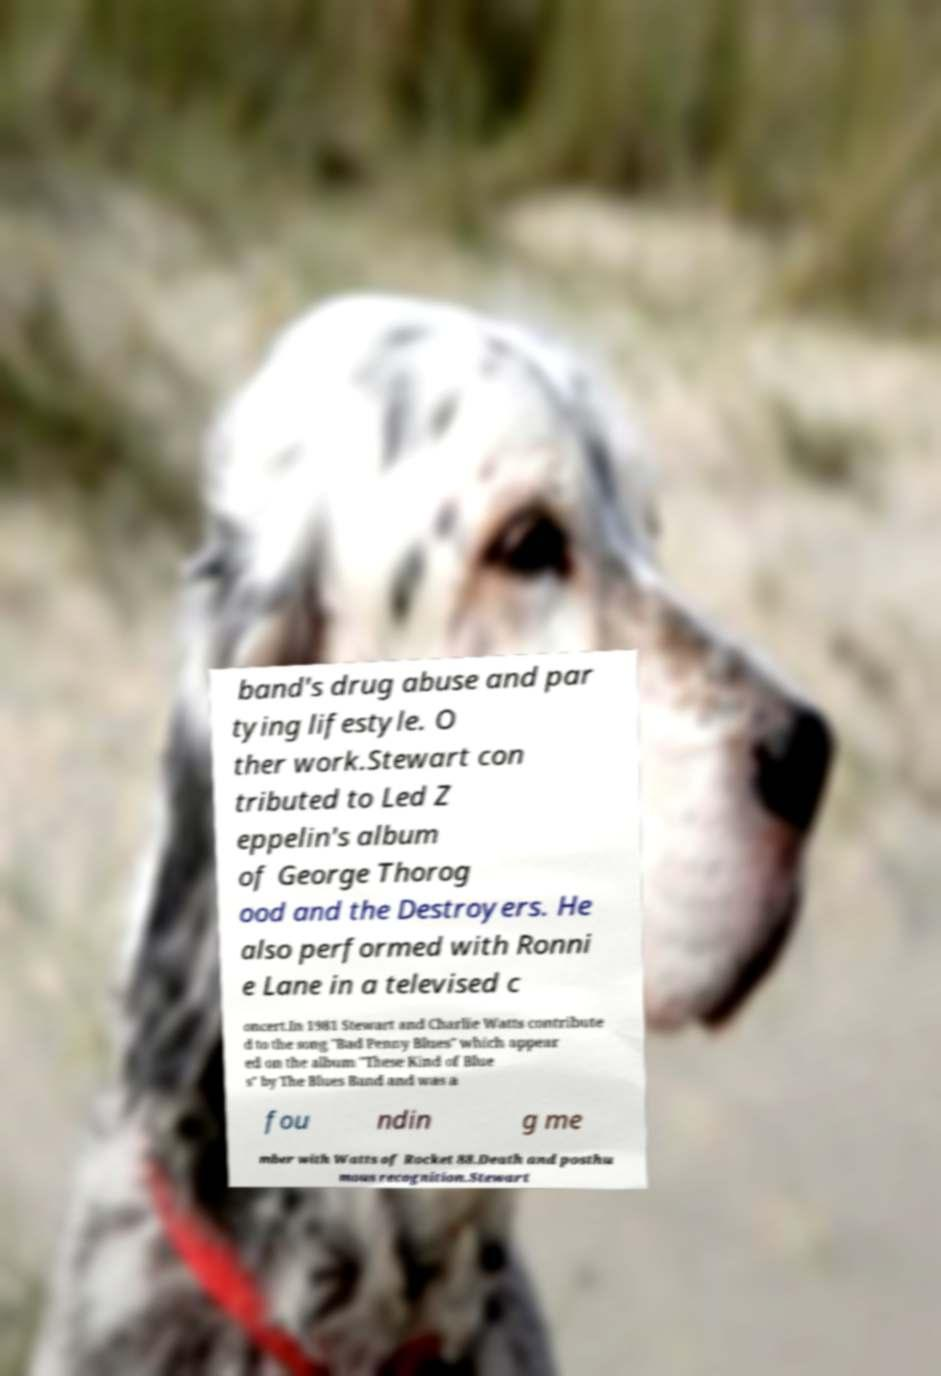What messages or text are displayed in this image? I need them in a readable, typed format. band's drug abuse and par tying lifestyle. O ther work.Stewart con tributed to Led Z eppelin's album of George Thorog ood and the Destroyers. He also performed with Ronni e Lane in a televised c oncert.In 1981 Stewart and Charlie Watts contribute d to the song "Bad Penny Blues" which appear ed on the album "These Kind of Blue s" by The Blues Band and was a fou ndin g me mber with Watts of Rocket 88.Death and posthu mous recognition.Stewart 